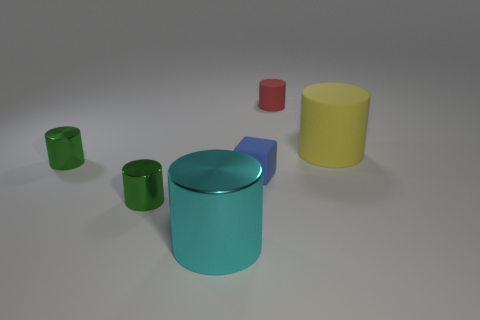Do the red cylinder and the blue matte object have the same size?
Ensure brevity in your answer.  Yes. What material is the large yellow object that is the same shape as the red thing?
Give a very brief answer. Rubber. What number of brown things are either small rubber objects or tiny metal cylinders?
Make the answer very short. 0. There is a large object behind the big metal thing; what material is it?
Your answer should be compact. Rubber. Is the number of big yellow matte cylinders greater than the number of large red metallic cubes?
Offer a very short reply. Yes. There is a large object that is behind the cyan shiny object; is it the same shape as the tiny blue object?
Make the answer very short. No. What number of big things are both behind the cyan shiny object and to the left of the big yellow cylinder?
Make the answer very short. 0. What number of small blue rubber objects have the same shape as the big metallic thing?
Your answer should be compact. 0. What color is the big object that is in front of the cylinder right of the small red cylinder?
Ensure brevity in your answer.  Cyan. Is the shape of the yellow thing the same as the metal thing behind the blue matte block?
Give a very brief answer. Yes. 